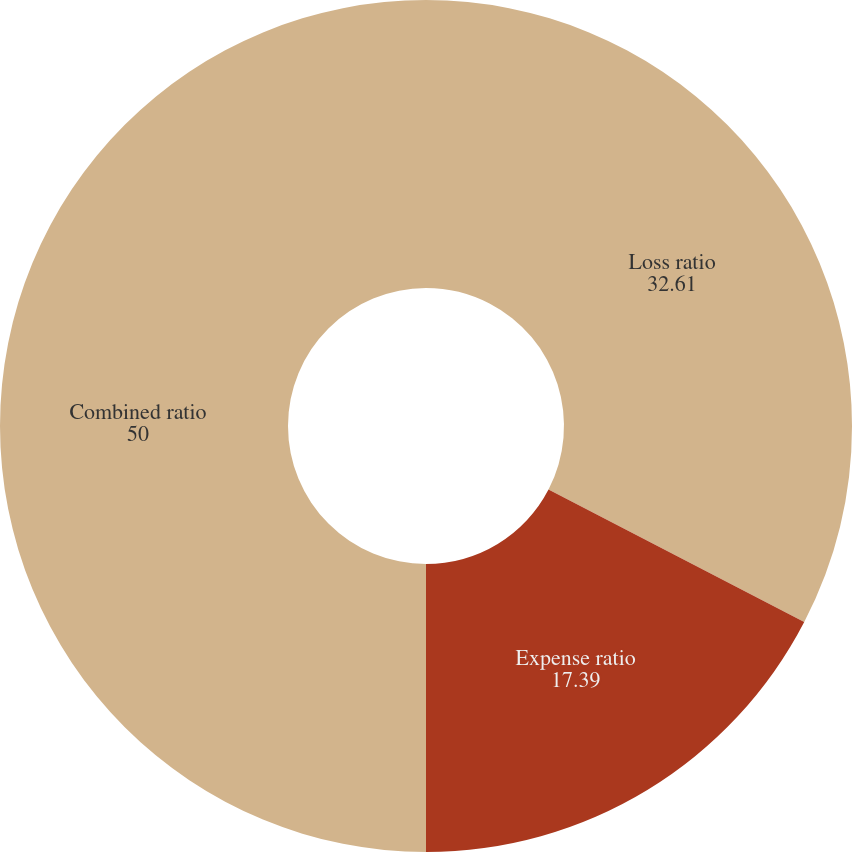Convert chart. <chart><loc_0><loc_0><loc_500><loc_500><pie_chart><fcel>Loss ratio<fcel>Expense ratio<fcel>Combined ratio<nl><fcel>32.61%<fcel>17.39%<fcel>50.0%<nl></chart> 